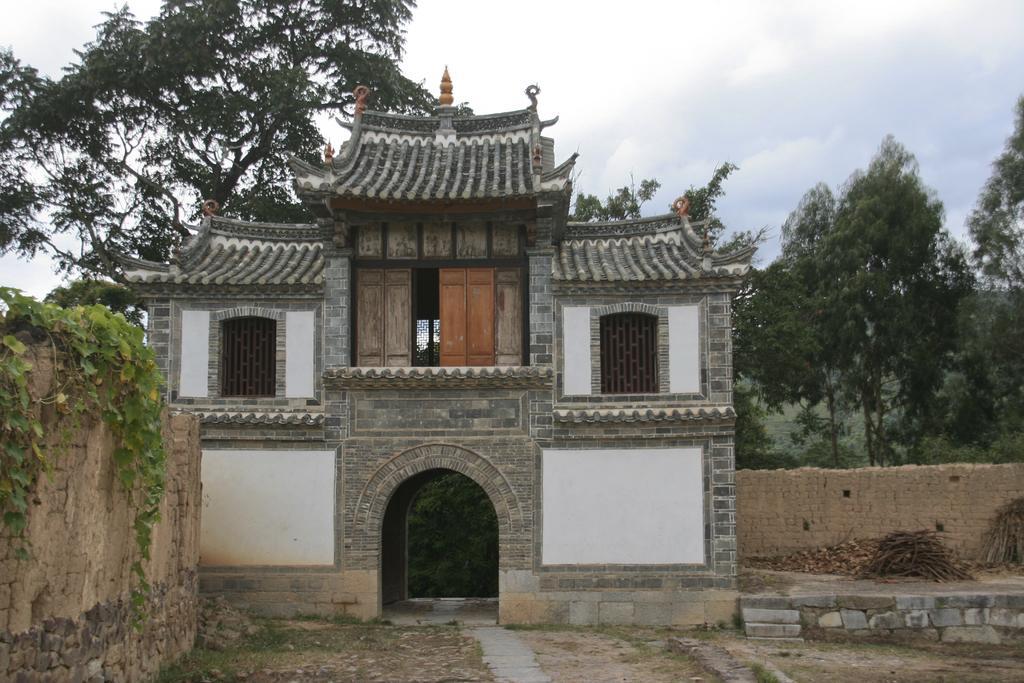How would you summarize this image in a sentence or two? In this image we can see a building, windows, doors, trees, creepers on the walls, pile of wooden sticks, ground and sky with clouds. 